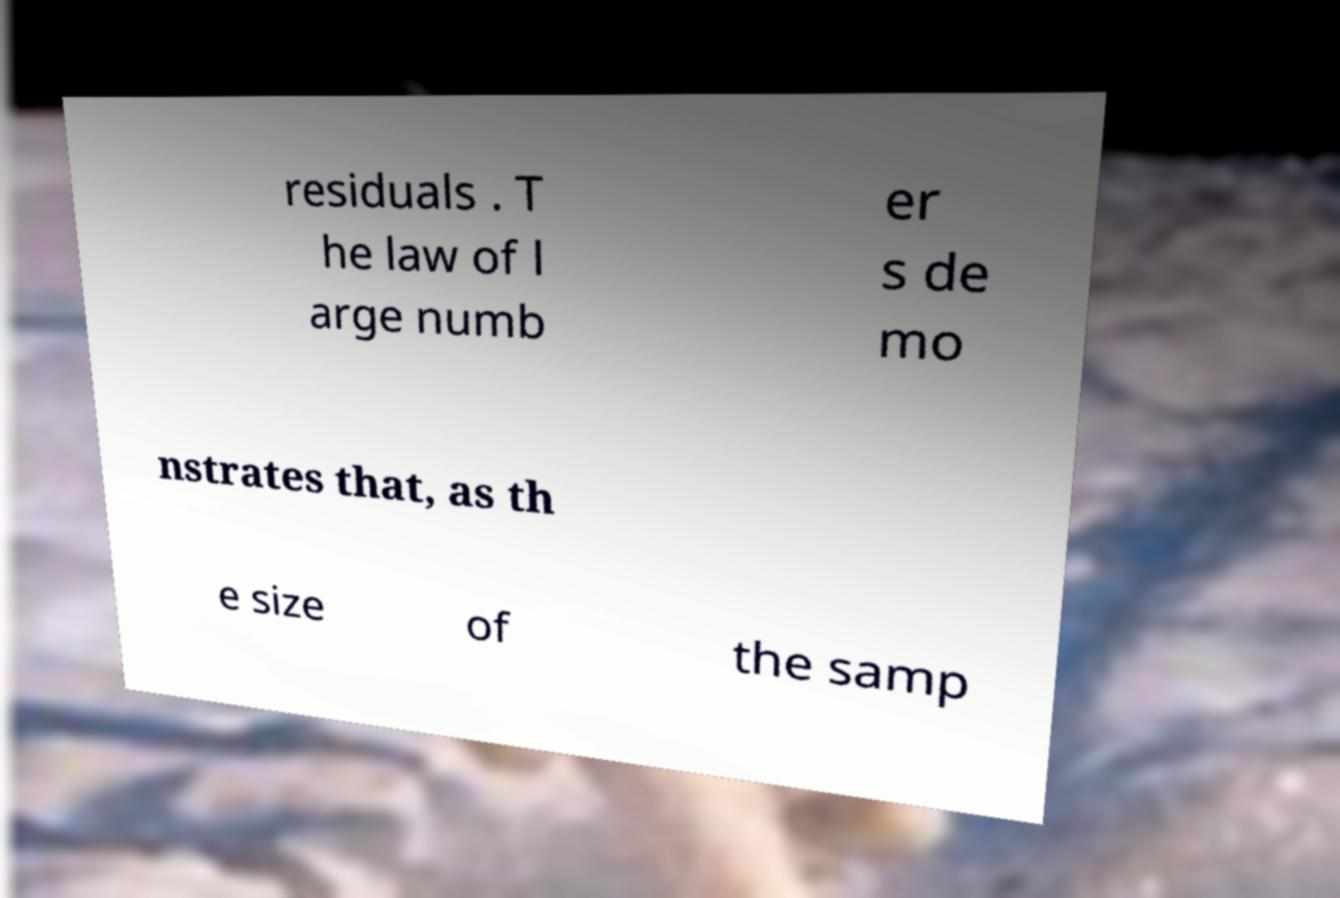For documentation purposes, I need the text within this image transcribed. Could you provide that? residuals . T he law of l arge numb er s de mo nstrates that, as th e size of the samp 